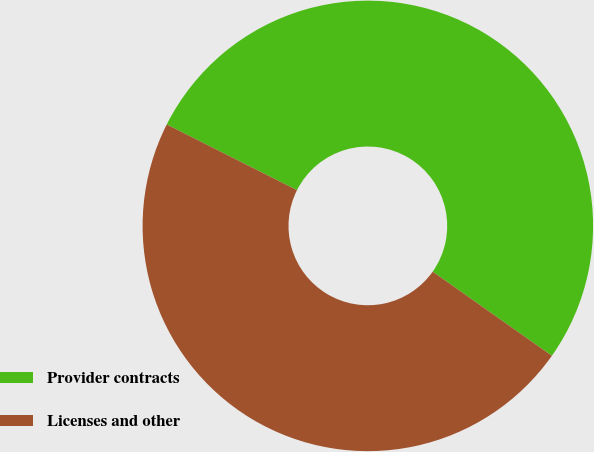Convert chart. <chart><loc_0><loc_0><loc_500><loc_500><pie_chart><fcel>Provider contracts<fcel>Licenses and other<nl><fcel>52.35%<fcel>47.65%<nl></chart> 